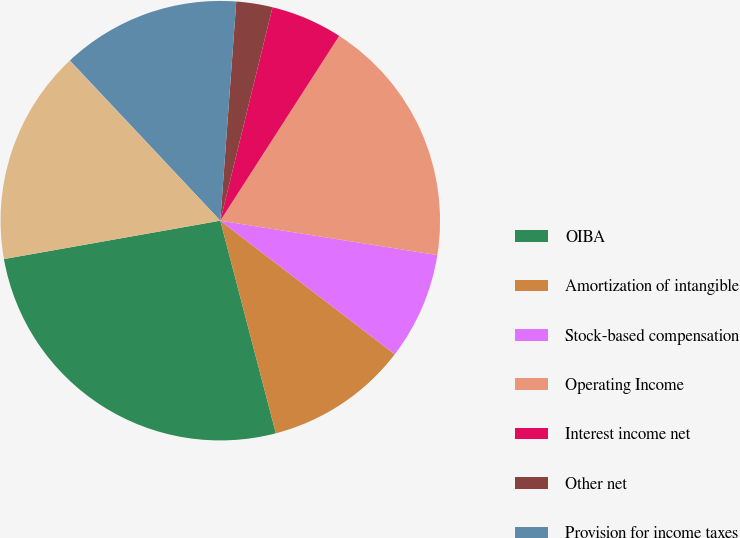Convert chart. <chart><loc_0><loc_0><loc_500><loc_500><pie_chart><fcel>OIBA<fcel>Amortization of intangible<fcel>Stock-based compensation<fcel>Operating Income<fcel>Interest income net<fcel>Other net<fcel>Provision for income taxes<fcel>Minority interest in (income)<fcel>Net Income<nl><fcel>26.27%<fcel>10.53%<fcel>7.9%<fcel>18.4%<fcel>5.28%<fcel>2.66%<fcel>13.15%<fcel>0.03%<fcel>15.77%<nl></chart> 